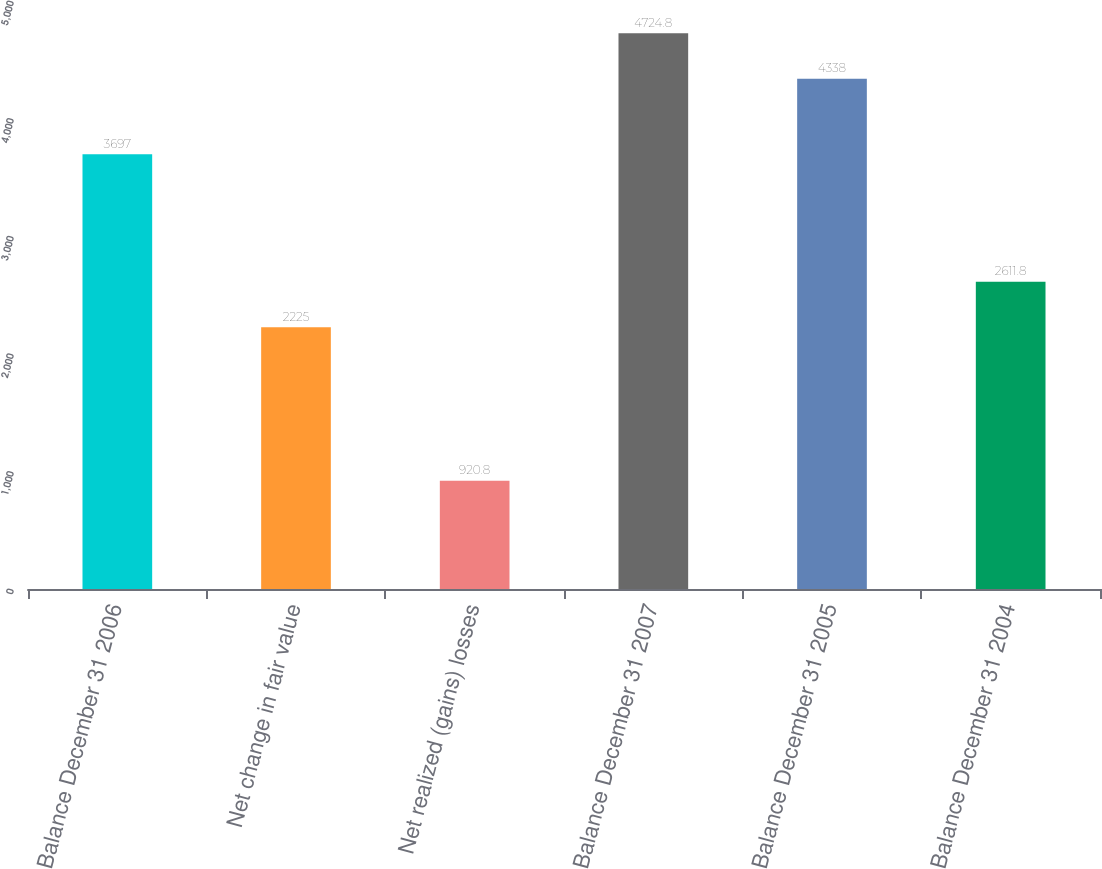<chart> <loc_0><loc_0><loc_500><loc_500><bar_chart><fcel>Balance December 31 2006<fcel>Net change in fair value<fcel>Net realized (gains) losses<fcel>Balance December 31 2007<fcel>Balance December 31 2005<fcel>Balance December 31 2004<nl><fcel>3697<fcel>2225<fcel>920.8<fcel>4724.8<fcel>4338<fcel>2611.8<nl></chart> 